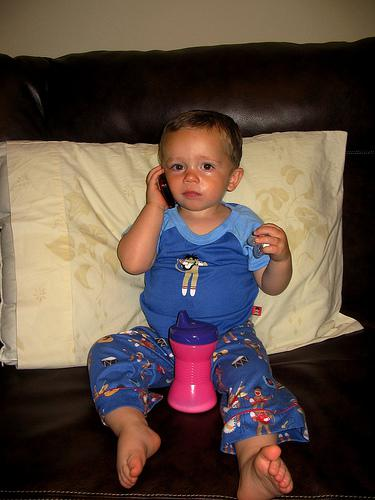Question: how is the baby positioned on the bed?
Choices:
A. He is sitting up.
B. He is standing.
C. He is lying down.
D. He is jumping.
Answer with the letter. Answer: A Question: what is he laying against?
Choices:
A. A blanket.
B. A headboard.
C. A pile of clothes.
D. A pillow.
Answer with the letter. Answer: D Question: where is the boy sitting?
Choices:
A. On a bed.
B. On a chair.
C. On the floor.
D. On a couch.
Answer with the letter. Answer: A Question: what is in front of him?
Choices:
A. A bottle.
B. A plate.
C. A sippy cup.
D. A fork.
Answer with the letter. Answer: C Question: what is he holding to his ear?
Choices:
A. A regular phone.
B. A cell phone.
C. A seashell.
D. A walkie-talkie.
Answer with the letter. Answer: B 